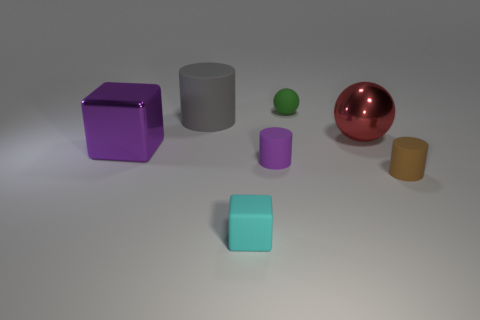There is a tiny thing that is the same color as the large block; what is its shape?
Keep it short and to the point. Cylinder. There is a green thing that is the same size as the cyan cube; what shape is it?
Your response must be concise. Sphere. The purple object that is behind the tiny rubber cylinder that is behind the small object on the right side of the small green matte sphere is what shape?
Ensure brevity in your answer.  Cube. Does the large rubber object have the same shape as the tiny brown matte object on the right side of the large cube?
Provide a succinct answer. Yes. How many big things are either metallic spheres or gray cylinders?
Your answer should be compact. 2. Is there another block of the same size as the purple cube?
Your answer should be compact. No. There is a block that is in front of the big metal thing on the left side of the small rubber cylinder left of the green object; what is its color?
Offer a terse response. Cyan. Do the brown cylinder and the sphere behind the large gray matte thing have the same material?
Give a very brief answer. Yes. What size is the brown matte object that is the same shape as the purple matte thing?
Provide a succinct answer. Small. Are there an equal number of matte objects that are left of the tiny brown cylinder and purple cylinders right of the purple cylinder?
Offer a very short reply. No. 